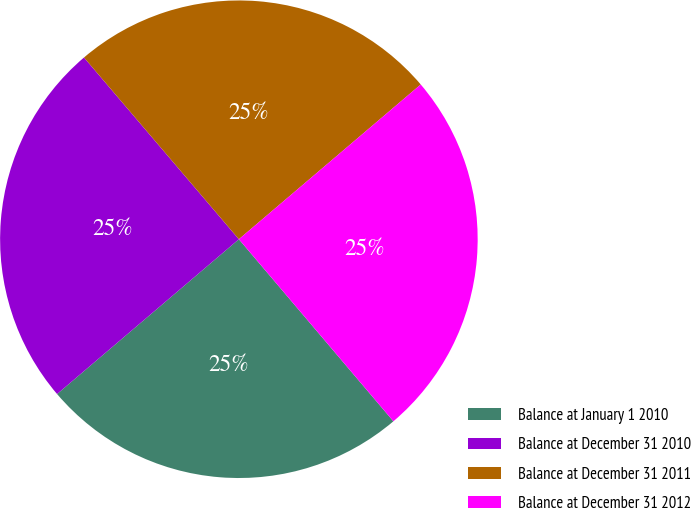Convert chart. <chart><loc_0><loc_0><loc_500><loc_500><pie_chart><fcel>Balance at January 1 2010<fcel>Balance at December 31 2010<fcel>Balance at December 31 2011<fcel>Balance at December 31 2012<nl><fcel>24.97%<fcel>24.99%<fcel>25.01%<fcel>25.02%<nl></chart> 